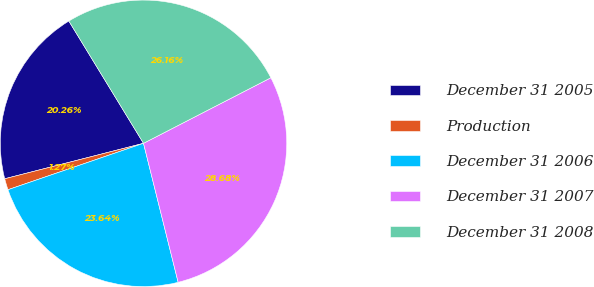<chart> <loc_0><loc_0><loc_500><loc_500><pie_chart><fcel>December 31 2005<fcel>Production<fcel>December 31 2006<fcel>December 31 2007<fcel>December 31 2008<nl><fcel>20.26%<fcel>1.27%<fcel>23.64%<fcel>28.68%<fcel>26.16%<nl></chart> 